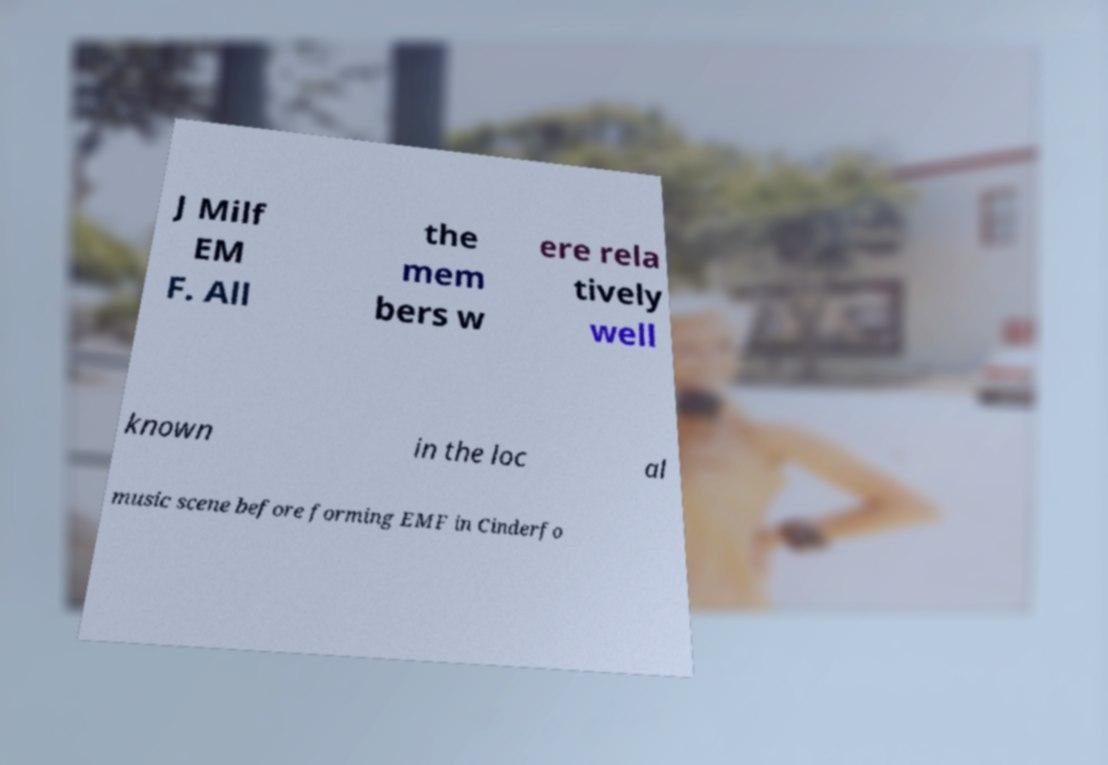I need the written content from this picture converted into text. Can you do that? J Milf EM F. All the mem bers w ere rela tively well known in the loc al music scene before forming EMF in Cinderfo 